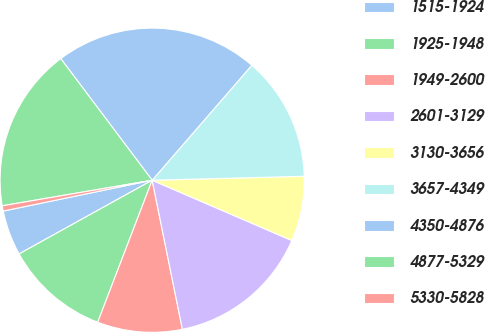<chart> <loc_0><loc_0><loc_500><loc_500><pie_chart><fcel>1515-1924<fcel>1925-1948<fcel>1949-2600<fcel>2601-3129<fcel>3130-3656<fcel>3657-4349<fcel>4350-4876<fcel>4877-5329<fcel>5330-5828<nl><fcel>4.8%<fcel>11.12%<fcel>9.01%<fcel>15.33%<fcel>6.9%<fcel>13.22%<fcel>21.62%<fcel>17.43%<fcel>0.56%<nl></chart> 